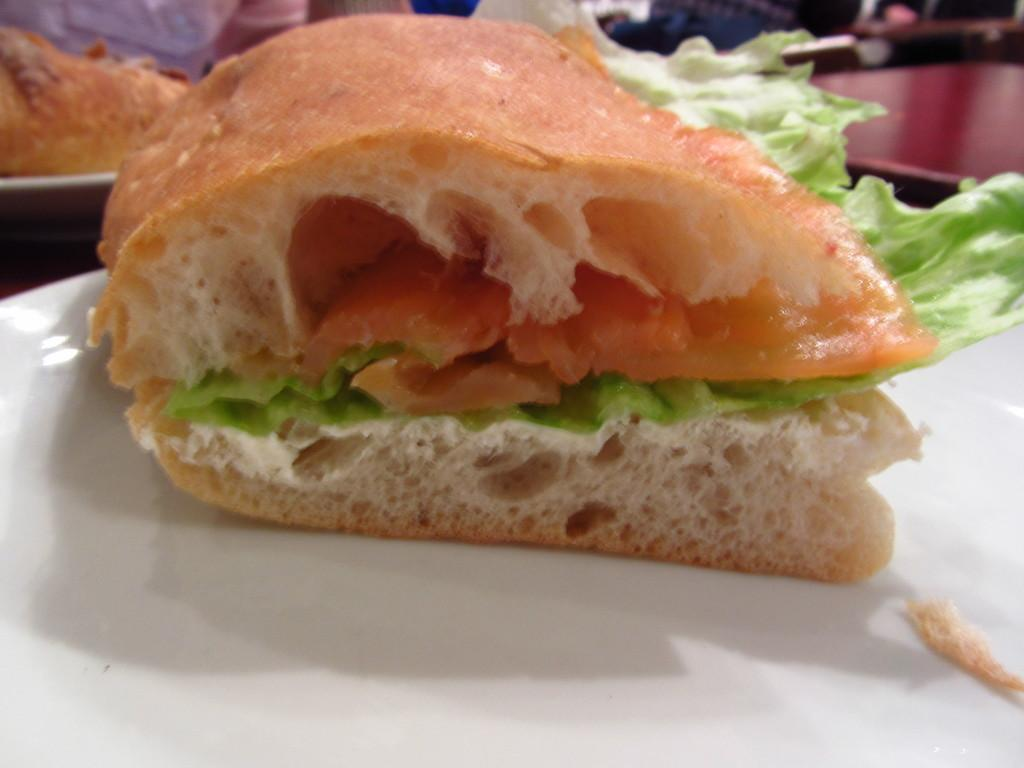What type of dishware is present in the image? There are white plates in the image. What is on the plates? There is food on the plates. Can you describe the colors of the food? The food has brown, red, and green colors. What color is the maroon-colored object in the image? The maroon-colored object in the image is maroon. What songs are being sung by the stranger in the image? There is no stranger or singing in the image; it only features white plates with food and a maroon-colored object. 